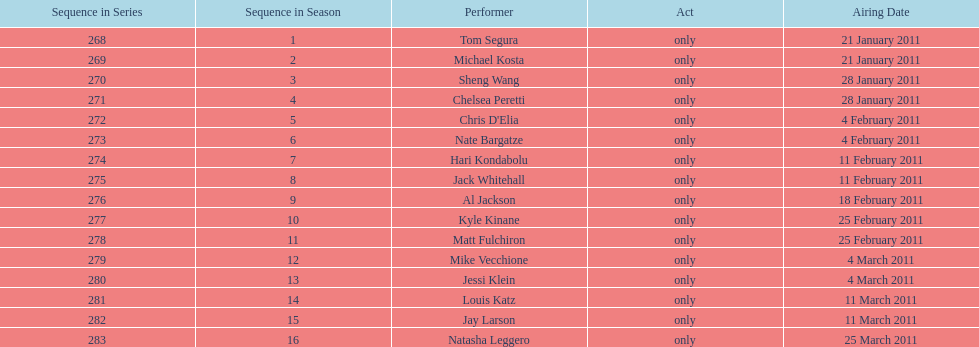How many different performers appeared during this season? 16. 